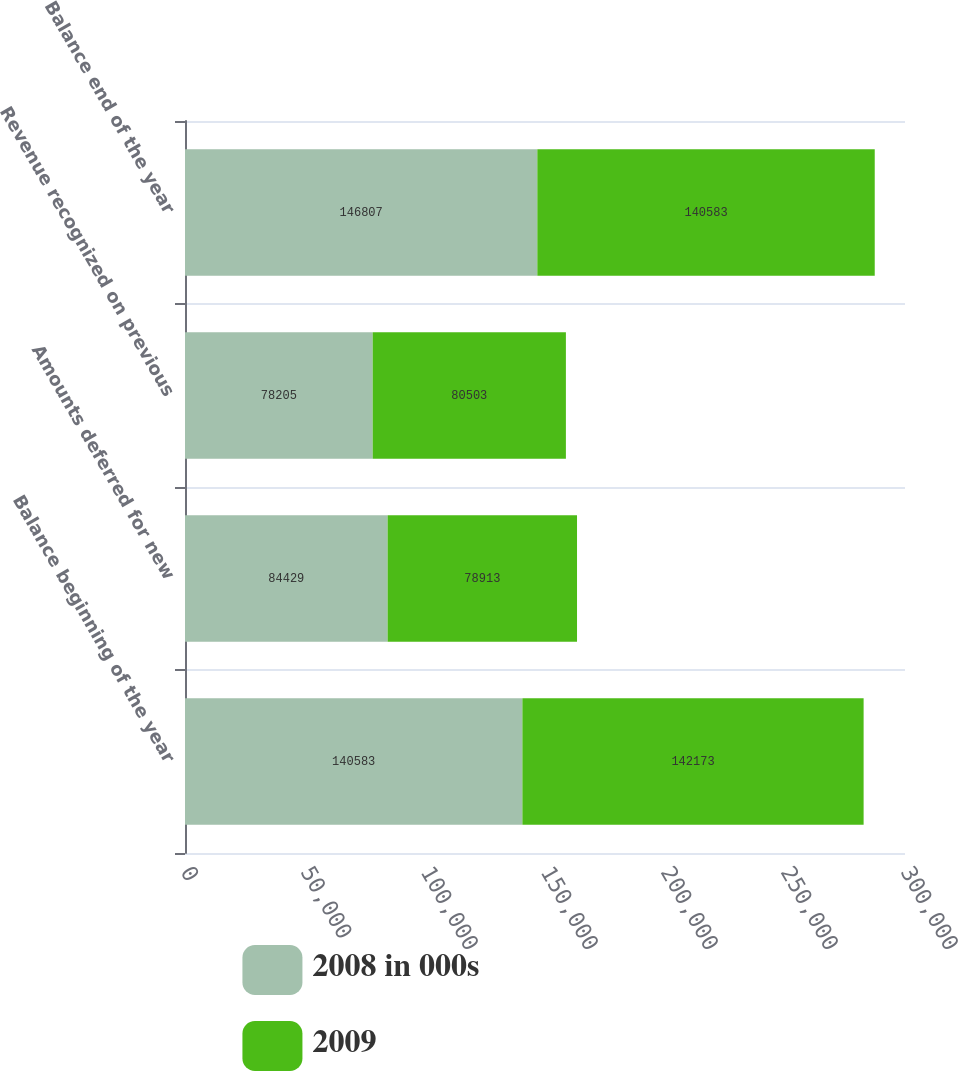Convert chart. <chart><loc_0><loc_0><loc_500><loc_500><stacked_bar_chart><ecel><fcel>Balance beginning of the year<fcel>Amounts deferred for new<fcel>Revenue recognized on previous<fcel>Balance end of the year<nl><fcel>2008 in 000s<fcel>140583<fcel>84429<fcel>78205<fcel>146807<nl><fcel>2009<fcel>142173<fcel>78913<fcel>80503<fcel>140583<nl></chart> 